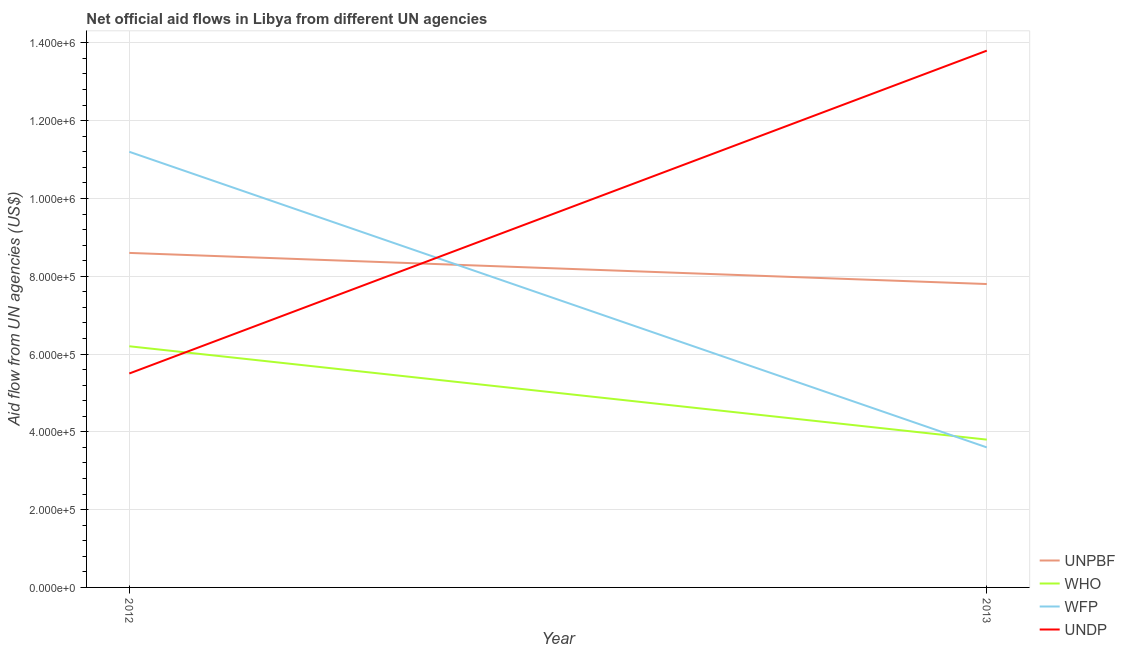Does the line corresponding to amount of aid given by undp intersect with the line corresponding to amount of aid given by wfp?
Give a very brief answer. Yes. What is the amount of aid given by undp in 2013?
Your answer should be compact. 1.38e+06. Across all years, what is the maximum amount of aid given by wfp?
Ensure brevity in your answer.  1.12e+06. Across all years, what is the minimum amount of aid given by undp?
Your answer should be compact. 5.50e+05. In which year was the amount of aid given by wfp maximum?
Offer a very short reply. 2012. In which year was the amount of aid given by wfp minimum?
Make the answer very short. 2013. What is the total amount of aid given by who in the graph?
Your answer should be very brief. 1.00e+06. What is the difference between the amount of aid given by undp in 2012 and that in 2013?
Give a very brief answer. -8.30e+05. What is the difference between the amount of aid given by unpbf in 2012 and the amount of aid given by undp in 2013?
Make the answer very short. -5.20e+05. What is the average amount of aid given by unpbf per year?
Make the answer very short. 8.20e+05. In the year 2012, what is the difference between the amount of aid given by who and amount of aid given by wfp?
Provide a succinct answer. -5.00e+05. What is the ratio of the amount of aid given by undp in 2012 to that in 2013?
Make the answer very short. 0.4. Is the amount of aid given by unpbf in 2012 less than that in 2013?
Provide a short and direct response. No. Does the amount of aid given by wfp monotonically increase over the years?
Provide a short and direct response. No. How many lines are there?
Your answer should be compact. 4. Does the graph contain any zero values?
Offer a terse response. No. Does the graph contain grids?
Give a very brief answer. Yes. Where does the legend appear in the graph?
Your answer should be compact. Bottom right. What is the title of the graph?
Offer a very short reply. Net official aid flows in Libya from different UN agencies. What is the label or title of the Y-axis?
Offer a very short reply. Aid flow from UN agencies (US$). What is the Aid flow from UN agencies (US$) of UNPBF in 2012?
Your answer should be very brief. 8.60e+05. What is the Aid flow from UN agencies (US$) of WHO in 2012?
Ensure brevity in your answer.  6.20e+05. What is the Aid flow from UN agencies (US$) of WFP in 2012?
Your answer should be very brief. 1.12e+06. What is the Aid flow from UN agencies (US$) of UNDP in 2012?
Keep it short and to the point. 5.50e+05. What is the Aid flow from UN agencies (US$) of UNPBF in 2013?
Make the answer very short. 7.80e+05. What is the Aid flow from UN agencies (US$) of WHO in 2013?
Make the answer very short. 3.80e+05. What is the Aid flow from UN agencies (US$) of UNDP in 2013?
Make the answer very short. 1.38e+06. Across all years, what is the maximum Aid flow from UN agencies (US$) of UNPBF?
Your answer should be compact. 8.60e+05. Across all years, what is the maximum Aid flow from UN agencies (US$) in WHO?
Give a very brief answer. 6.20e+05. Across all years, what is the maximum Aid flow from UN agencies (US$) of WFP?
Make the answer very short. 1.12e+06. Across all years, what is the maximum Aid flow from UN agencies (US$) in UNDP?
Give a very brief answer. 1.38e+06. Across all years, what is the minimum Aid flow from UN agencies (US$) of UNPBF?
Your answer should be compact. 7.80e+05. Across all years, what is the minimum Aid flow from UN agencies (US$) of WHO?
Offer a very short reply. 3.80e+05. Across all years, what is the minimum Aid flow from UN agencies (US$) of WFP?
Your answer should be very brief. 3.60e+05. Across all years, what is the minimum Aid flow from UN agencies (US$) of UNDP?
Offer a terse response. 5.50e+05. What is the total Aid flow from UN agencies (US$) in UNPBF in the graph?
Offer a very short reply. 1.64e+06. What is the total Aid flow from UN agencies (US$) in WHO in the graph?
Your answer should be very brief. 1.00e+06. What is the total Aid flow from UN agencies (US$) in WFP in the graph?
Keep it short and to the point. 1.48e+06. What is the total Aid flow from UN agencies (US$) of UNDP in the graph?
Offer a terse response. 1.93e+06. What is the difference between the Aid flow from UN agencies (US$) in WHO in 2012 and that in 2013?
Keep it short and to the point. 2.40e+05. What is the difference between the Aid flow from UN agencies (US$) of WFP in 2012 and that in 2013?
Your answer should be very brief. 7.60e+05. What is the difference between the Aid flow from UN agencies (US$) of UNDP in 2012 and that in 2013?
Provide a short and direct response. -8.30e+05. What is the difference between the Aid flow from UN agencies (US$) in UNPBF in 2012 and the Aid flow from UN agencies (US$) in WHO in 2013?
Offer a very short reply. 4.80e+05. What is the difference between the Aid flow from UN agencies (US$) in UNPBF in 2012 and the Aid flow from UN agencies (US$) in UNDP in 2013?
Offer a terse response. -5.20e+05. What is the difference between the Aid flow from UN agencies (US$) in WHO in 2012 and the Aid flow from UN agencies (US$) in UNDP in 2013?
Provide a short and direct response. -7.60e+05. What is the average Aid flow from UN agencies (US$) of UNPBF per year?
Give a very brief answer. 8.20e+05. What is the average Aid flow from UN agencies (US$) of WHO per year?
Your answer should be compact. 5.00e+05. What is the average Aid flow from UN agencies (US$) in WFP per year?
Offer a very short reply. 7.40e+05. What is the average Aid flow from UN agencies (US$) in UNDP per year?
Give a very brief answer. 9.65e+05. In the year 2012, what is the difference between the Aid flow from UN agencies (US$) of UNPBF and Aid flow from UN agencies (US$) of WHO?
Your answer should be very brief. 2.40e+05. In the year 2012, what is the difference between the Aid flow from UN agencies (US$) of UNPBF and Aid flow from UN agencies (US$) of WFP?
Offer a terse response. -2.60e+05. In the year 2012, what is the difference between the Aid flow from UN agencies (US$) of UNPBF and Aid flow from UN agencies (US$) of UNDP?
Your response must be concise. 3.10e+05. In the year 2012, what is the difference between the Aid flow from UN agencies (US$) in WHO and Aid flow from UN agencies (US$) in WFP?
Ensure brevity in your answer.  -5.00e+05. In the year 2012, what is the difference between the Aid flow from UN agencies (US$) in WFP and Aid flow from UN agencies (US$) in UNDP?
Make the answer very short. 5.70e+05. In the year 2013, what is the difference between the Aid flow from UN agencies (US$) of UNPBF and Aid flow from UN agencies (US$) of WHO?
Ensure brevity in your answer.  4.00e+05. In the year 2013, what is the difference between the Aid flow from UN agencies (US$) of UNPBF and Aid flow from UN agencies (US$) of UNDP?
Ensure brevity in your answer.  -6.00e+05. In the year 2013, what is the difference between the Aid flow from UN agencies (US$) in WFP and Aid flow from UN agencies (US$) in UNDP?
Ensure brevity in your answer.  -1.02e+06. What is the ratio of the Aid flow from UN agencies (US$) in UNPBF in 2012 to that in 2013?
Your answer should be compact. 1.1. What is the ratio of the Aid flow from UN agencies (US$) in WHO in 2012 to that in 2013?
Make the answer very short. 1.63. What is the ratio of the Aid flow from UN agencies (US$) of WFP in 2012 to that in 2013?
Ensure brevity in your answer.  3.11. What is the ratio of the Aid flow from UN agencies (US$) of UNDP in 2012 to that in 2013?
Make the answer very short. 0.4. What is the difference between the highest and the second highest Aid flow from UN agencies (US$) in UNPBF?
Provide a short and direct response. 8.00e+04. What is the difference between the highest and the second highest Aid flow from UN agencies (US$) in WHO?
Offer a terse response. 2.40e+05. What is the difference between the highest and the second highest Aid flow from UN agencies (US$) in WFP?
Offer a very short reply. 7.60e+05. What is the difference between the highest and the second highest Aid flow from UN agencies (US$) of UNDP?
Provide a succinct answer. 8.30e+05. What is the difference between the highest and the lowest Aid flow from UN agencies (US$) in UNPBF?
Ensure brevity in your answer.  8.00e+04. What is the difference between the highest and the lowest Aid flow from UN agencies (US$) in WFP?
Your answer should be very brief. 7.60e+05. What is the difference between the highest and the lowest Aid flow from UN agencies (US$) in UNDP?
Offer a terse response. 8.30e+05. 